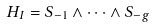Convert formula to latex. <formula><loc_0><loc_0><loc_500><loc_500>H _ { I } = S _ { - 1 } \wedge \cdots \wedge S _ { - g }</formula> 